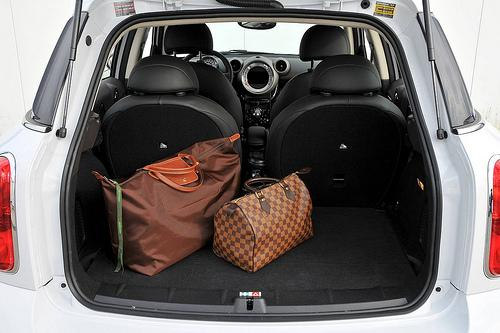How many seats are in the back of the car, and what color are they? There are two seats in the back of the car, and they are black leather. Identify the main object in the image and describe its primary feature. A white car with its trunk door open, revealing two bags inside. Choose three features present in the car's interior and describe them. The black driver's steering wheel, center console between the two front seats, and the panel of buttons in front of the gear shift. What object is holding the trunk door open, and what color is it? A thin rod is holding the trunk door open, and it is black. Provide a brief description of the vehicle and its primary action in the image. A white SUV with its trunk door open, showing some bags inside. What are the colors and patterns of the two bags in the trunk of the car? One bag is dark brown with light brown handles, and the other is brown with a checkerboard print. Which side of the car is the steering wheel located and what color is it? The steering wheel is on the left side of the car and is black. Describe the headrests in the front part of the vehicle. There are two headrests, one on the driver seat that is black and another on the passenger seat that is gray. 